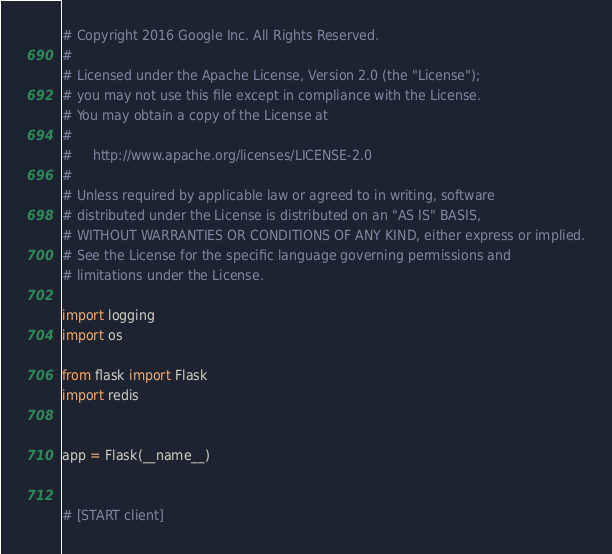Convert code to text. <code><loc_0><loc_0><loc_500><loc_500><_Python_># Copyright 2016 Google Inc. All Rights Reserved.
#
# Licensed under the Apache License, Version 2.0 (the "License");
# you may not use this file except in compliance with the License.
# You may obtain a copy of the License at
#
#     http://www.apache.org/licenses/LICENSE-2.0
#
# Unless required by applicable law or agreed to in writing, software
# distributed under the License is distributed on an "AS IS" BASIS,
# WITHOUT WARRANTIES OR CONDITIONS OF ANY KIND, either express or implied.
# See the License for the specific language governing permissions and
# limitations under the License.

import logging
import os

from flask import Flask
import redis


app = Flask(__name__)


# [START client]</code> 